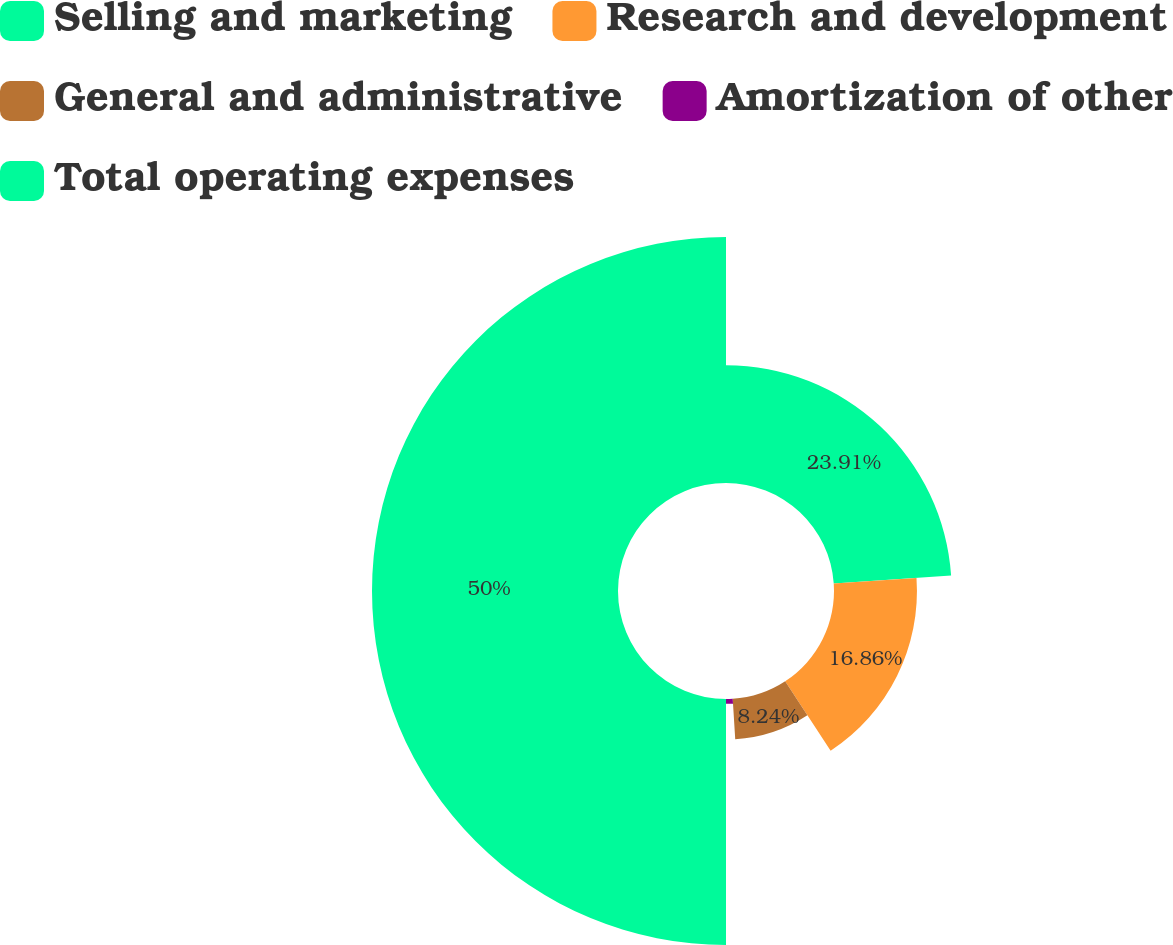<chart> <loc_0><loc_0><loc_500><loc_500><pie_chart><fcel>Selling and marketing<fcel>Research and development<fcel>General and administrative<fcel>Amortization of other<fcel>Total operating expenses<nl><fcel>23.91%<fcel>16.86%<fcel>8.24%<fcel>0.99%<fcel>50.0%<nl></chart> 